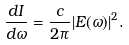<formula> <loc_0><loc_0><loc_500><loc_500>\frac { d I } { d \omega } = \frac { c } { 2 \pi } | { { E } { ( \omega ) } } | ^ { 2 } .</formula> 